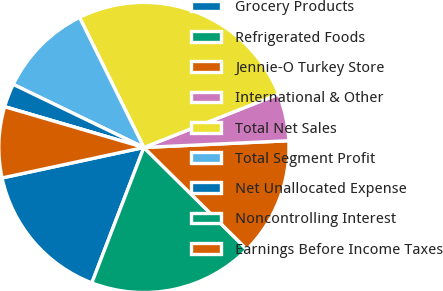Convert chart to OTSL. <chart><loc_0><loc_0><loc_500><loc_500><pie_chart><fcel>Grocery Products<fcel>Refrigerated Foods<fcel>Jennie-O Turkey Store<fcel>International & Other<fcel>Total Net Sales<fcel>Total Segment Profit<fcel>Net Unallocated Expense<fcel>Noncontrolling Interest<fcel>Earnings Before Income Taxes<nl><fcel>15.79%<fcel>18.42%<fcel>13.16%<fcel>5.26%<fcel>26.31%<fcel>10.53%<fcel>2.63%<fcel>0.0%<fcel>7.9%<nl></chart> 